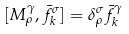<formula> <loc_0><loc_0><loc_500><loc_500>[ M _ { \rho } ^ { \gamma } , \bar { f } _ { k } ^ { \sigma } ] = \delta _ { \rho } ^ { \sigma } \bar { f } _ { k } ^ { \gamma }</formula> 